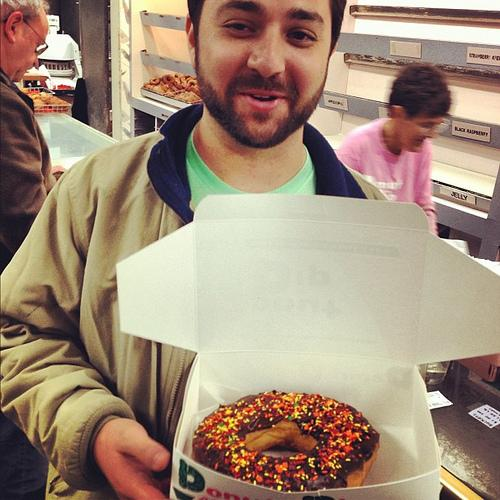Describe the appearance of the donut that the man is holding. The donut is large, with chocolate frosting, colorful sprinkles, and a hole in the center. How is the box that the man is holding designed? It's a white open box with green and red letters. It contains a large chocolate donut with sprinkles. Describe the surroundings of the image. The image is set in a supermarket, with a white large fridge behind the people and donuts on the shelf. Count the number of donuts in the image, including those on the shelf. There are multiple donuts featured; the big donut in the box, and several donuts on the shelf. Name three elements in the image that are related to the donut and describe their characteristics. Chocolate icing on the donut is dark and shiny, sprinkles are small and colorful, and the hole in the center is circular and empty. Determine the type of location where the scene in the image is taking place. The scene appears to be taking place in a donut shop or bakery within a supermarket. What is the main focus of the image, and what is its appearance? The main focus of the image is a big donut with chocolate icing and sprinkles in an open white box, held by a man with a brown jacket and green shirt. What does the donut's presentation evoke in terms of sentiment? The donut's presentation evokes feelings of indulgence, happiness, and satisfaction. Identify two people present in the image and describe their clothing. An older man is wearing a brown jacket, green shirt, and glasses. A woman behind the counter has a pink shirt. What information can you get about the man holding the box with the donut in it? The man is smiling, wearing glasses, has dark hair, a beard, and a moustache. He's also wearing a green shirt and brown jacket. Is the man in the image wearing glasses? Yes Notice the blue balloon tied to the man's hand. No, it's not mentioned in the image. In the image, can you recognize the location where the three people are present? A supermarket What does the woman behind the counter wear in the image describe that? A pink shirt Describe the most prominent object in the white box and its features. A big chocolate donut with sprinkles on top and a hole in the center Which statement is true about the man's facial hair in the image? a) He has a clean-shaven face. b) He has a beard and mustache. c) He only has a mustache. He has a beard and mustache. From the image, describe the appearance of the older man at the counter. Man in profile with a brown jacket and glasses What is the expression of the man holding the white box in the image? Smiling Describe the lining of the man's jacket. Navy blue Examine the image and describe the hair color of the man holding the box. Dark What is the color of the woman's shirt on the right side of the image? Pink How is the top of the white box in the image? Opened Write a caption for the image depicting the displayed content and the people present. Three people in a supermarket, man holding a white box with a big donut on it, woman wearing pink behind the counter. What do you observe about the beard and mustache of the man in the image? The beard and mustache are trim Identify the activity that the man in the image is engaged in. Holding a white box with a big donut on it What color is the man's jacket in the image? Brown What is the color of the man's shirt in the image? Green What color are the letters on the white donut box? Green and red Identify and describe the object on the shelf in the image. Donuts Based on the image, write a detailed caption about the donut in the box. Big chocolate donut with chips on it and sprinkles on top in a white open box. 